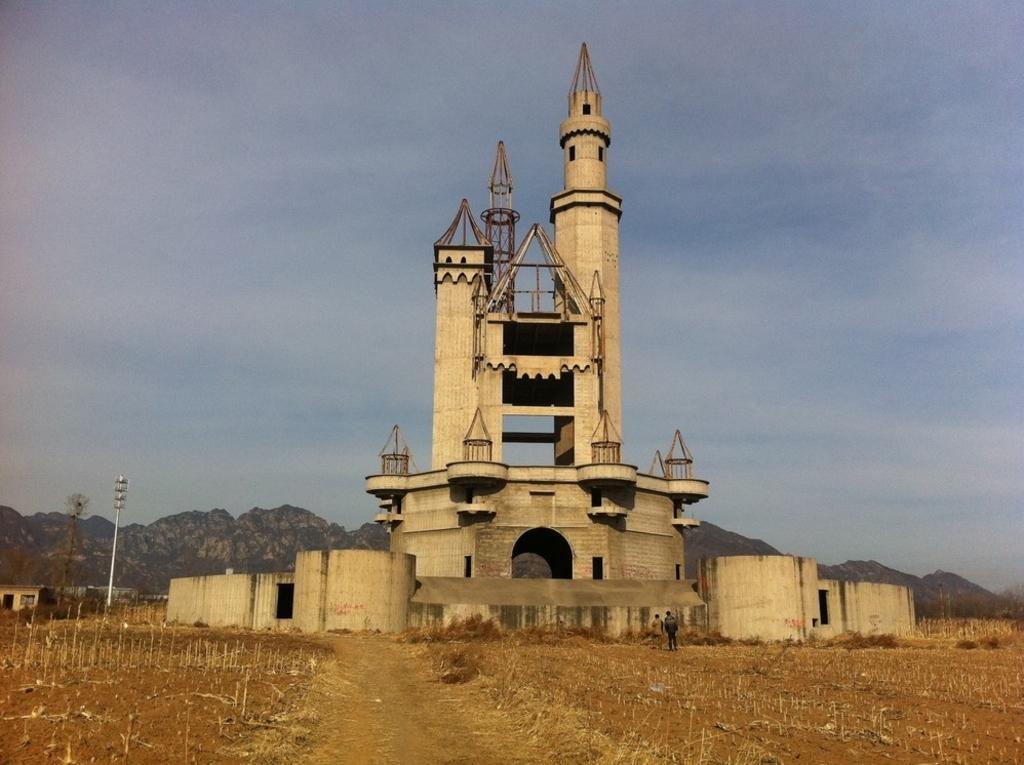In one or two sentences, can you explain what this image depicts? This picture consists of building , in front of building I can see persons and back side of the building I can see the hill and pole visible on the left side ,at the top I can see the sky. 